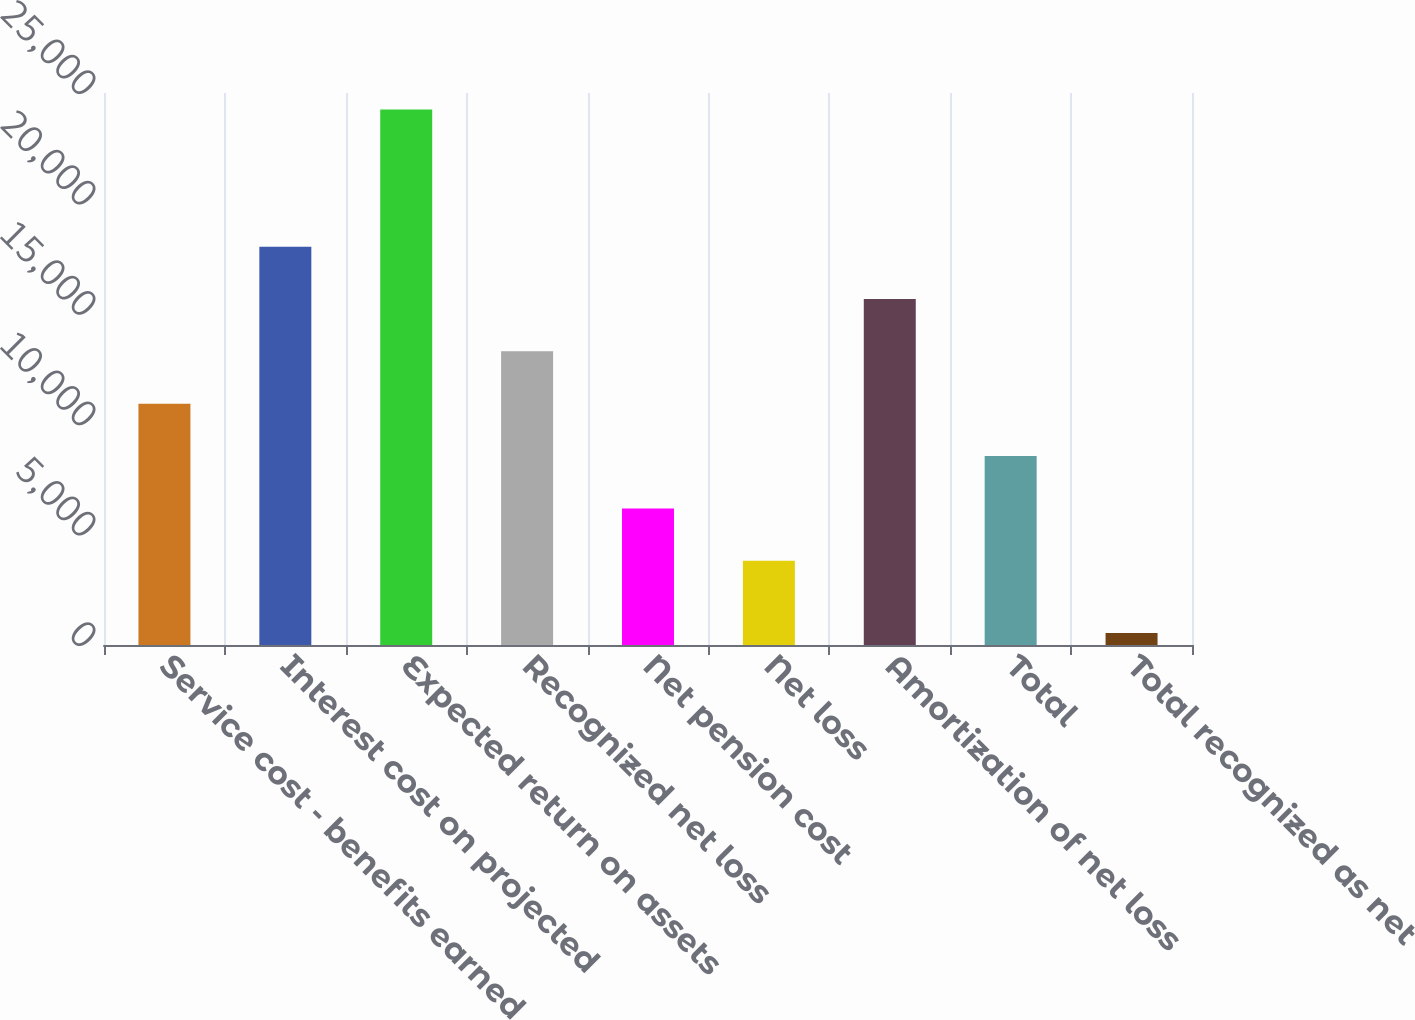Convert chart. <chart><loc_0><loc_0><loc_500><loc_500><bar_chart><fcel>Service cost - benefits earned<fcel>Interest cost on projected<fcel>Expected return on assets<fcel>Recognized net loss<fcel>Net pension cost<fcel>Net loss<fcel>Amortization of net loss<fcel>Total<fcel>Total recognized as net<nl><fcel>10928.4<fcel>18040.8<fcel>24248<fcel>13299.2<fcel>6186.8<fcel>3816<fcel>15670<fcel>8557.6<fcel>540<nl></chart> 